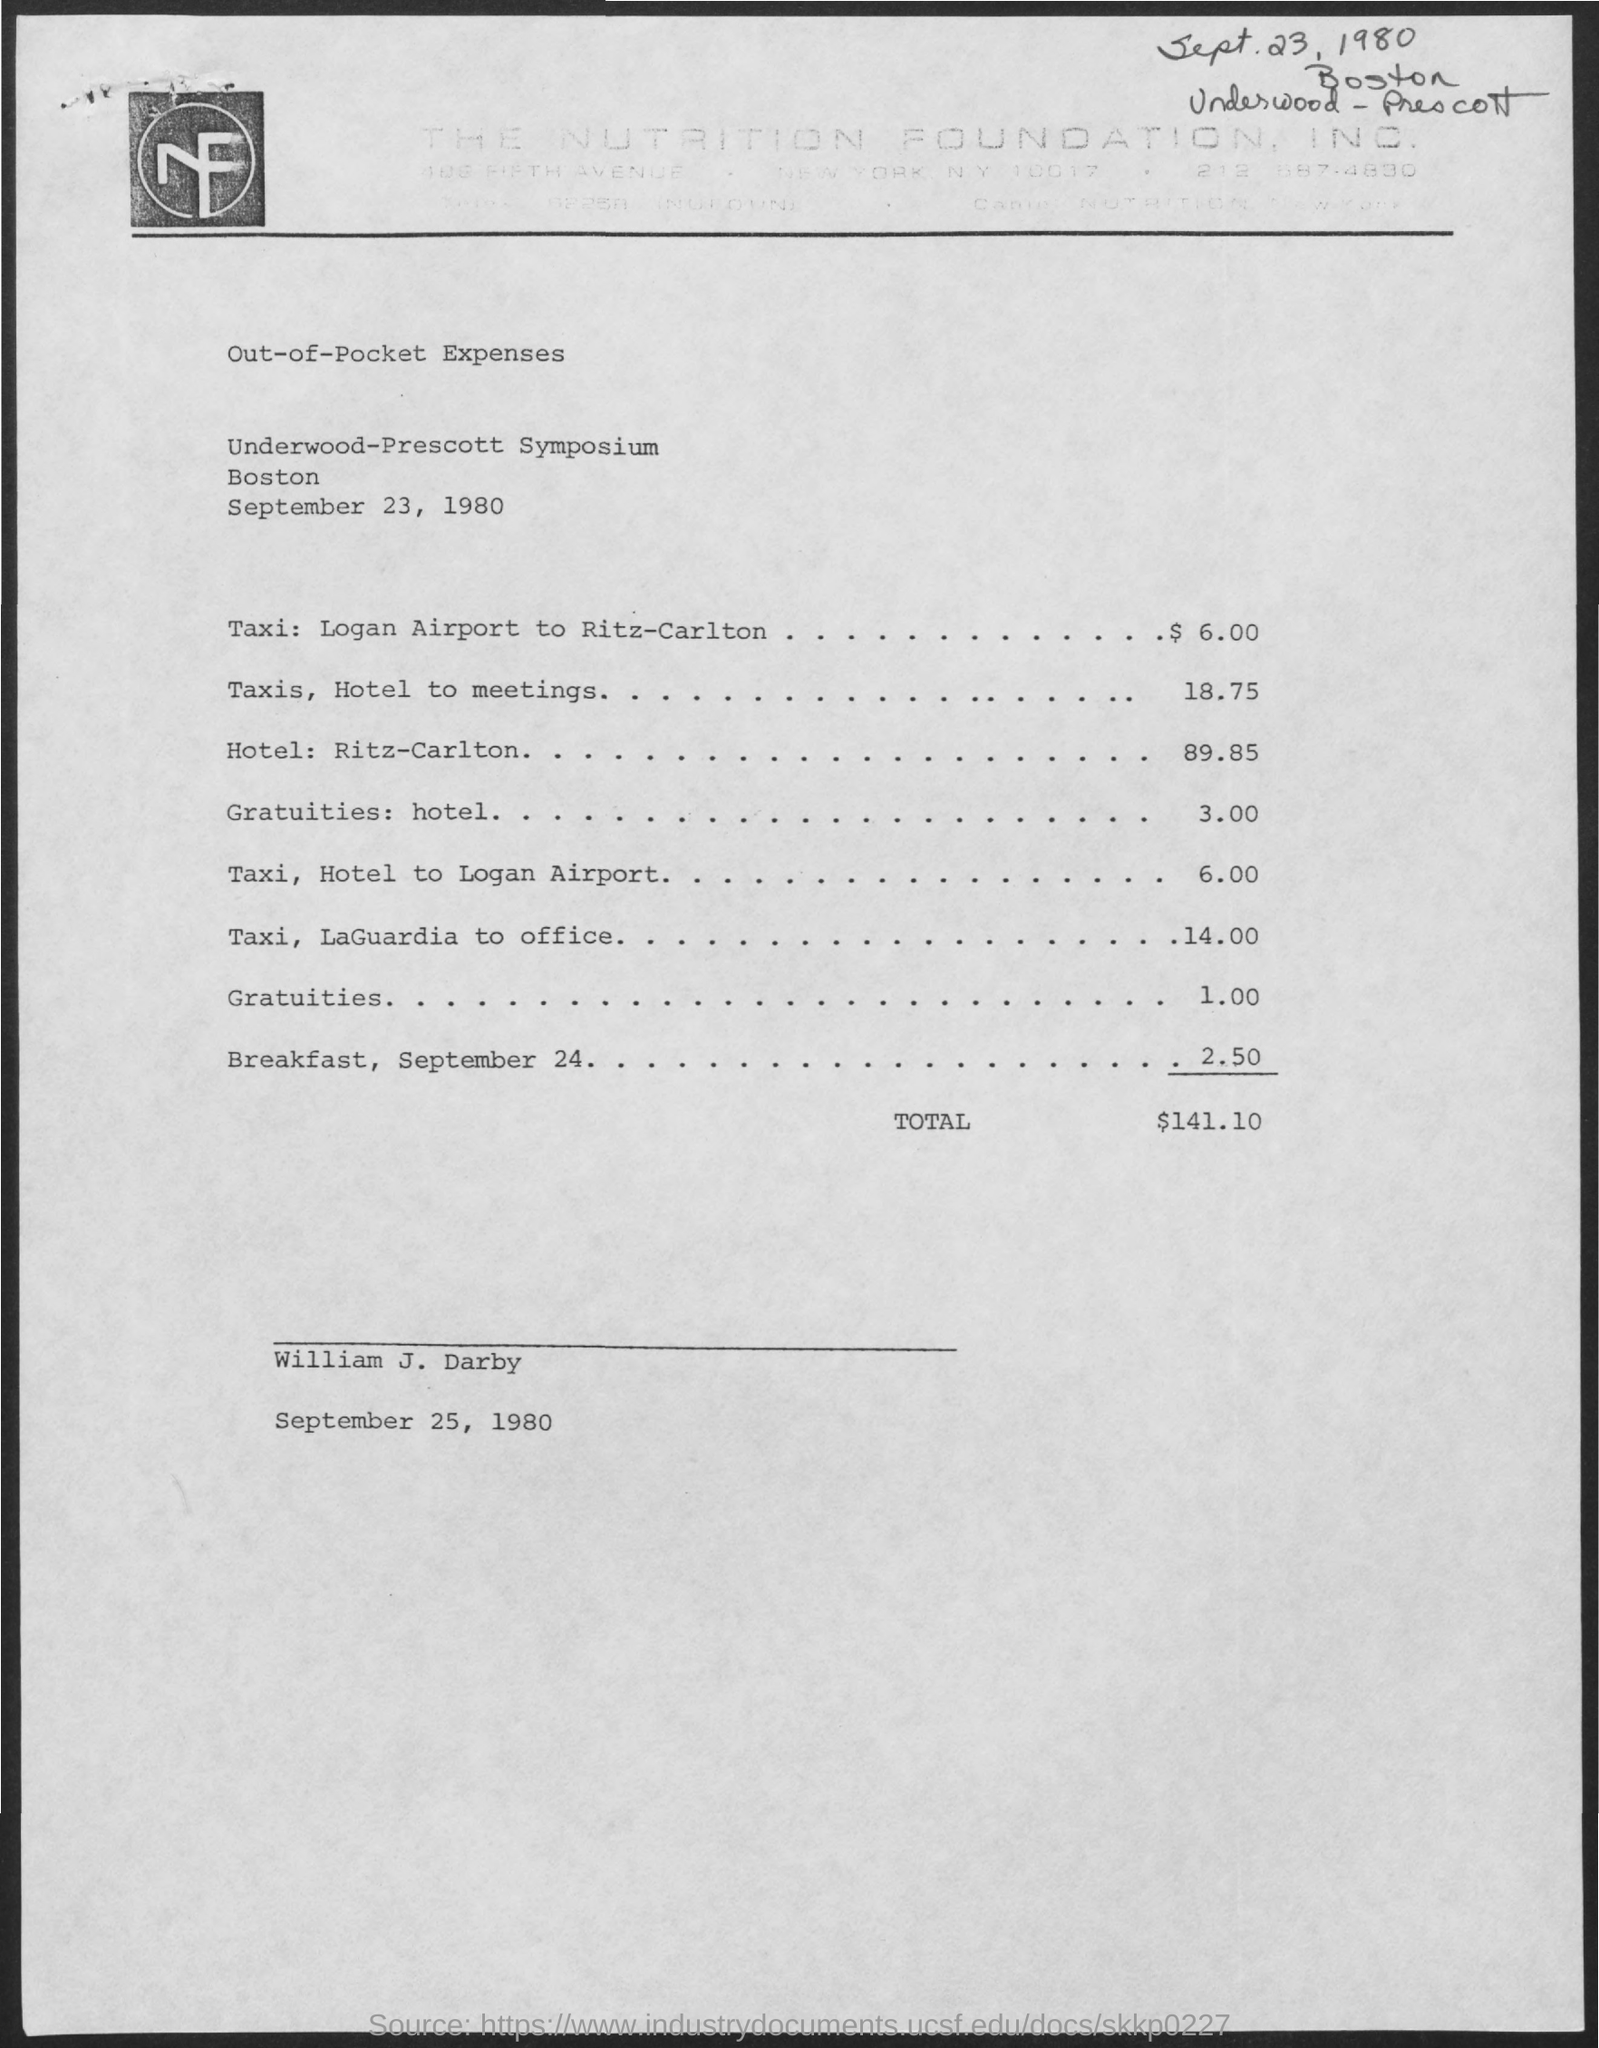how much expenses does gratuities: hotel include? The image shows a document listing various expenses, where 'Gratuities: hotel' has an associated cost of $3.00. This represents a small tip given for the service at the hotel during the stay captured in this document. 